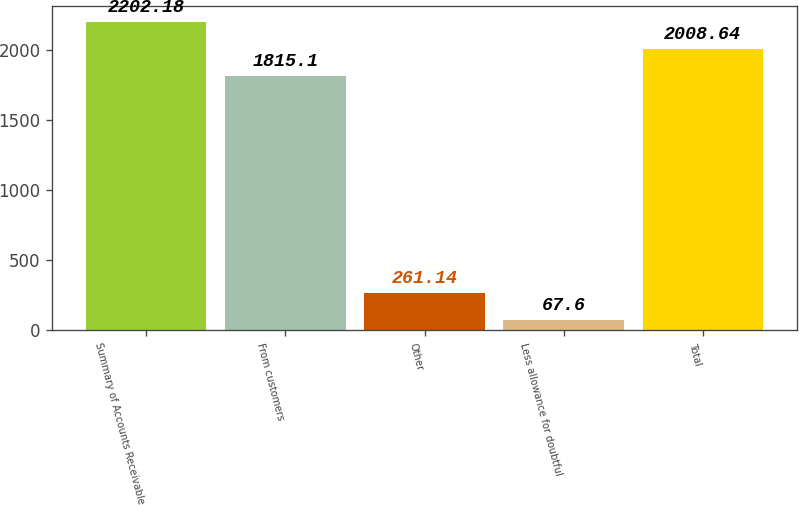Convert chart. <chart><loc_0><loc_0><loc_500><loc_500><bar_chart><fcel>Summary of Accounts Receivable<fcel>From customers<fcel>Other<fcel>Less allowance for doubtful<fcel>Total<nl><fcel>2202.18<fcel>1815.1<fcel>261.14<fcel>67.6<fcel>2008.64<nl></chart> 